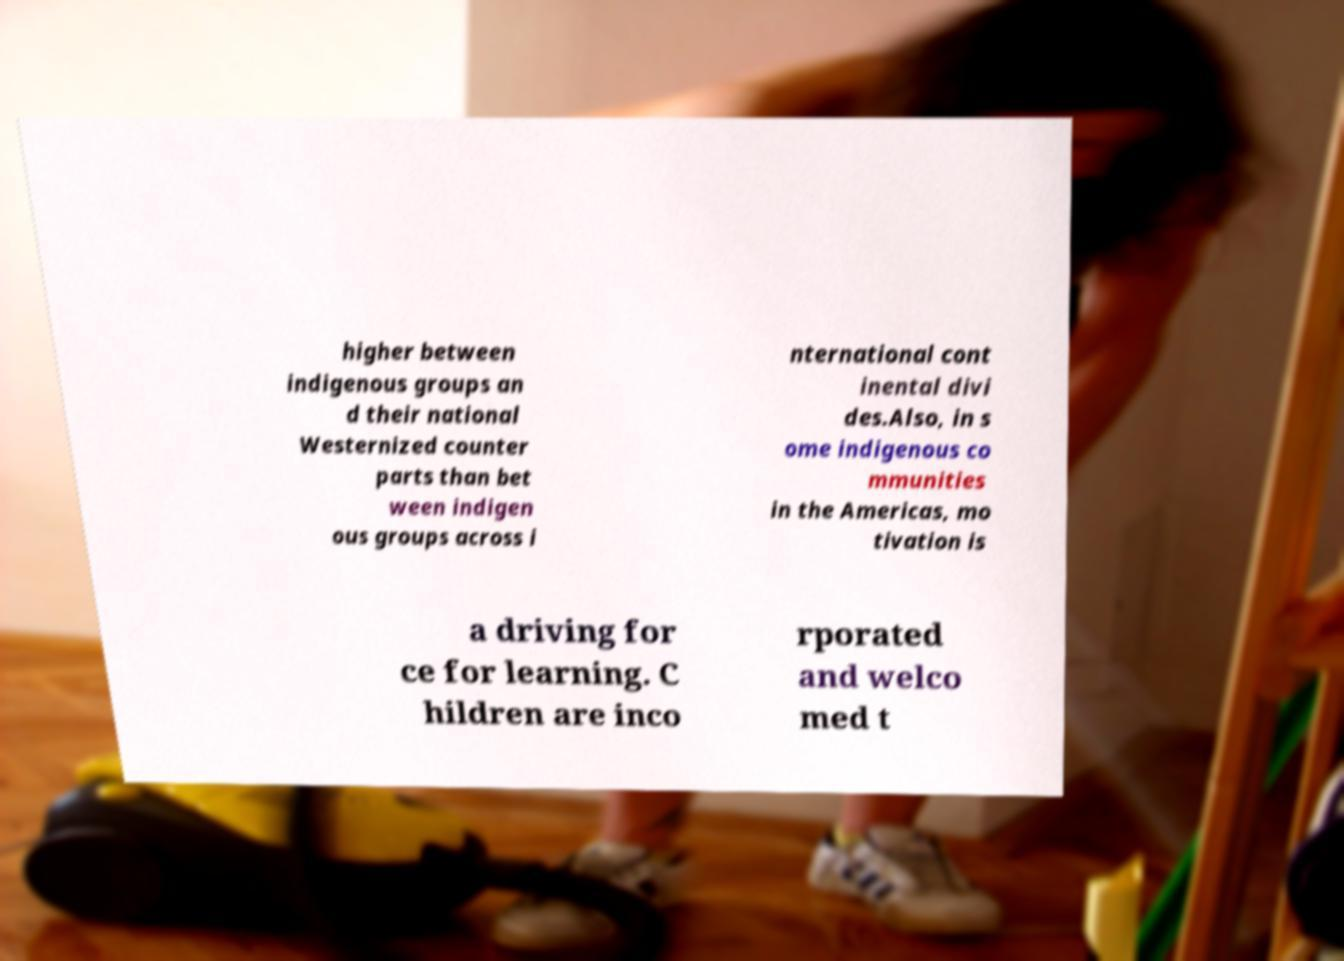Could you assist in decoding the text presented in this image and type it out clearly? higher between indigenous groups an d their national Westernized counter parts than bet ween indigen ous groups across i nternational cont inental divi des.Also, in s ome indigenous co mmunities in the Americas, mo tivation is a driving for ce for learning. C hildren are inco rporated and welco med t 